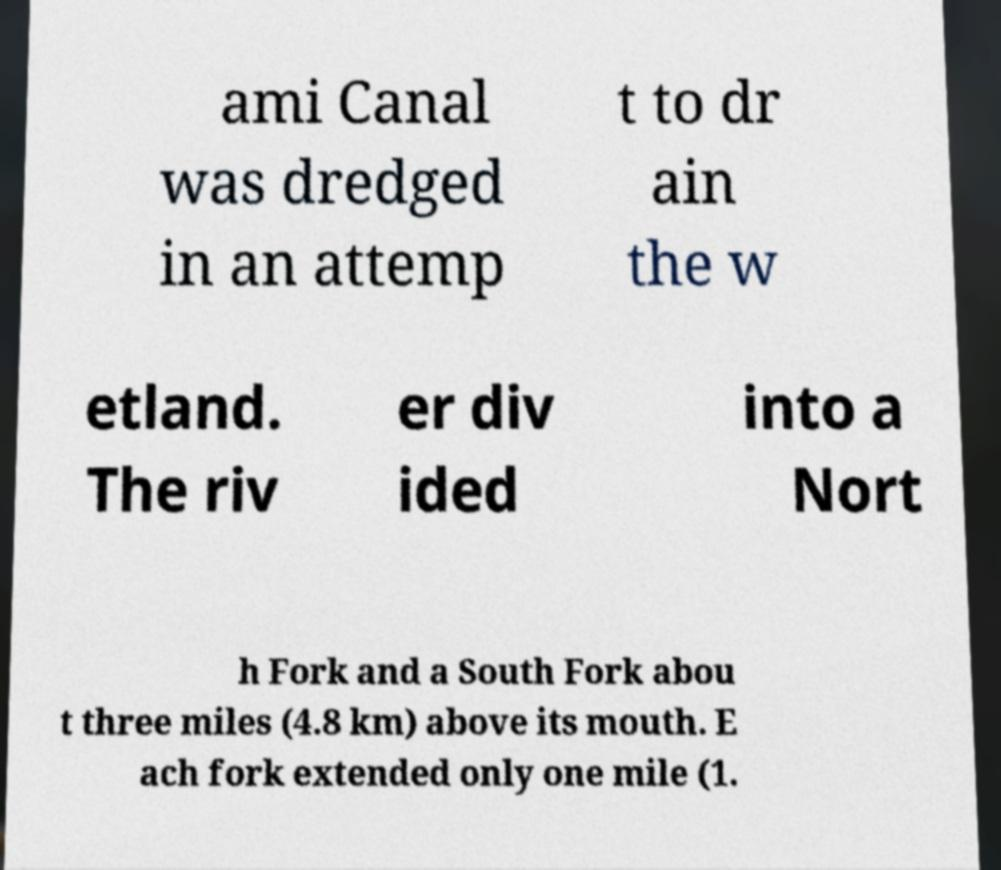Please identify and transcribe the text found in this image. ami Canal was dredged in an attemp t to dr ain the w etland. The riv er div ided into a Nort h Fork and a South Fork abou t three miles (4.8 km) above its mouth. E ach fork extended only one mile (1. 